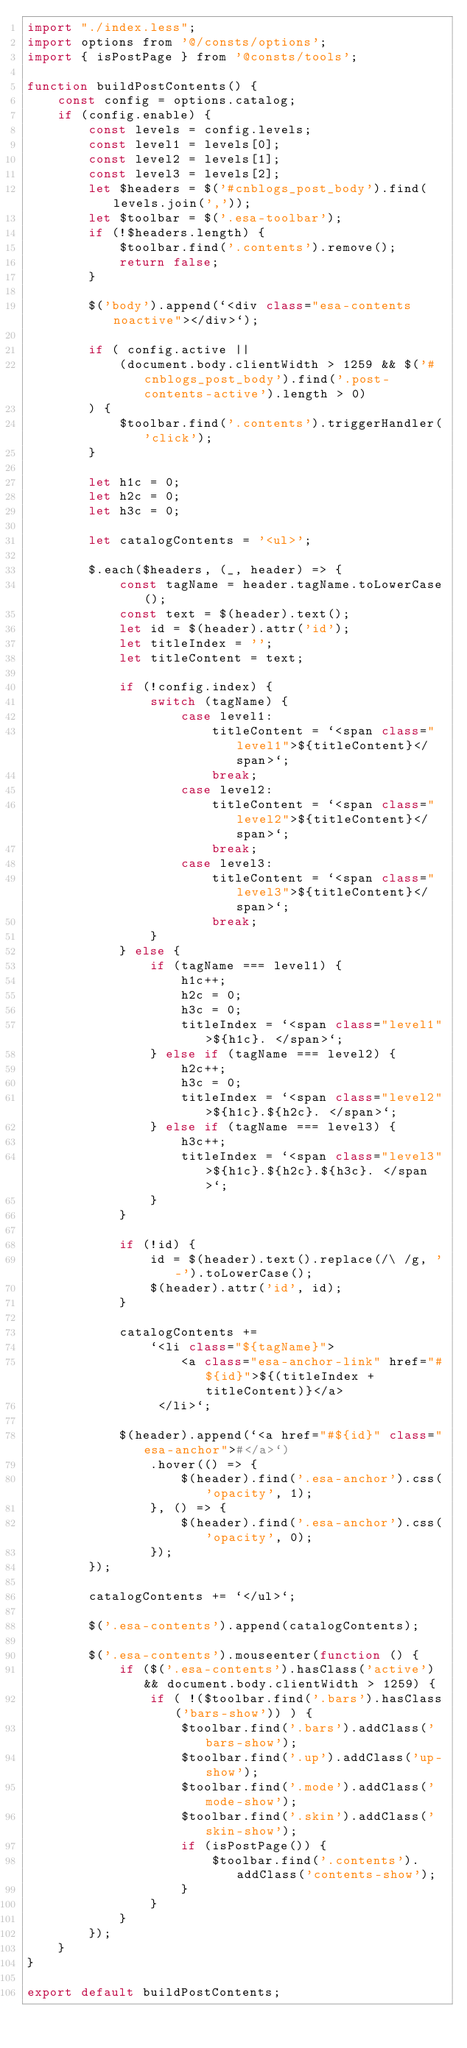<code> <loc_0><loc_0><loc_500><loc_500><_JavaScript_>import "./index.less";
import options from '@/consts/options';
import { isPostPage } from '@consts/tools';

function buildPostContents() {
    const config = options.catalog;
    if (config.enable) {
        const levels = config.levels;
        const level1 = levels[0];
        const level2 = levels[1];
        const level3 = levels[2];
        let $headers = $('#cnblogs_post_body').find(levels.join(','));
        let $toolbar = $('.esa-toolbar');
        if (!$headers.length) {
            $toolbar.find('.contents').remove();
            return false;
        }

        $('body').append(`<div class="esa-contents noactive"></div>`);

        if ( config.active ||
            (document.body.clientWidth > 1259 && $('#cnblogs_post_body').find('.post-contents-active').length > 0)
        ) {
            $toolbar.find('.contents').triggerHandler('click');
        }

        let h1c = 0;
        let h2c = 0;
        let h3c = 0;

        let catalogContents = '<ul>';

        $.each($headers, (_, header) => {
            const tagName = header.tagName.toLowerCase();
            const text = $(header).text();
            let id = $(header).attr('id');
            let titleIndex = '';
            let titleContent = text;

            if (!config.index) {
                switch (tagName) {
                    case level1:
                        titleContent = `<span class="level1">${titleContent}</span>`;
                        break;
                    case level2:
                        titleContent = `<span class="level2">${titleContent}</span>`;
                        break;
                    case level3:
                        titleContent = `<span class="level3">${titleContent}</span>`;
                        break;
                }
            } else {
                if (tagName === level1) {
                    h1c++;
                    h2c = 0;
                    h3c = 0;
                    titleIndex = `<span class="level1">${h1c}. </span>`;
                } else if (tagName === level2) {
                    h2c++;
                    h3c = 0;
                    titleIndex = `<span class="level2">${h1c}.${h2c}. </span>`;
                } else if (tagName === level3) {
                    h3c++;
                    titleIndex = `<span class="level3">${h1c}.${h2c}.${h3c}. </span>`;
                }
            }

            if (!id) {
                id = $(header).text().replace(/\ /g, '-').toLowerCase();
                $(header).attr('id', id);
            }

            catalogContents +=
                `<li class="${tagName}">
                    <a class="esa-anchor-link" href="#${id}">${(titleIndex + titleContent)}</a>
                 </li>`;

            $(header).append(`<a href="#${id}" class="esa-anchor">#</a>`)
                .hover(() => {
                    $(header).find('.esa-anchor').css('opacity', 1);
                }, () => {
                    $(header).find('.esa-anchor').css('opacity', 0);
                });
        });

        catalogContents += `</ul>`;

        $('.esa-contents').append(catalogContents);

        $('.esa-contents').mouseenter(function () {
            if ($('.esa-contents').hasClass('active') && document.body.clientWidth > 1259) {
                if ( !($toolbar.find('.bars').hasClass('bars-show')) ) {
                    $toolbar.find('.bars').addClass('bars-show');
                    $toolbar.find('.up').addClass('up-show');
                    $toolbar.find('.mode').addClass('mode-show');
                    $toolbar.find('.skin').addClass('skin-show');
                    if (isPostPage()) {
                        $toolbar.find('.contents').addClass('contents-show');
                    }
                }
            }
        });
    }
}

export default buildPostContents;
</code> 